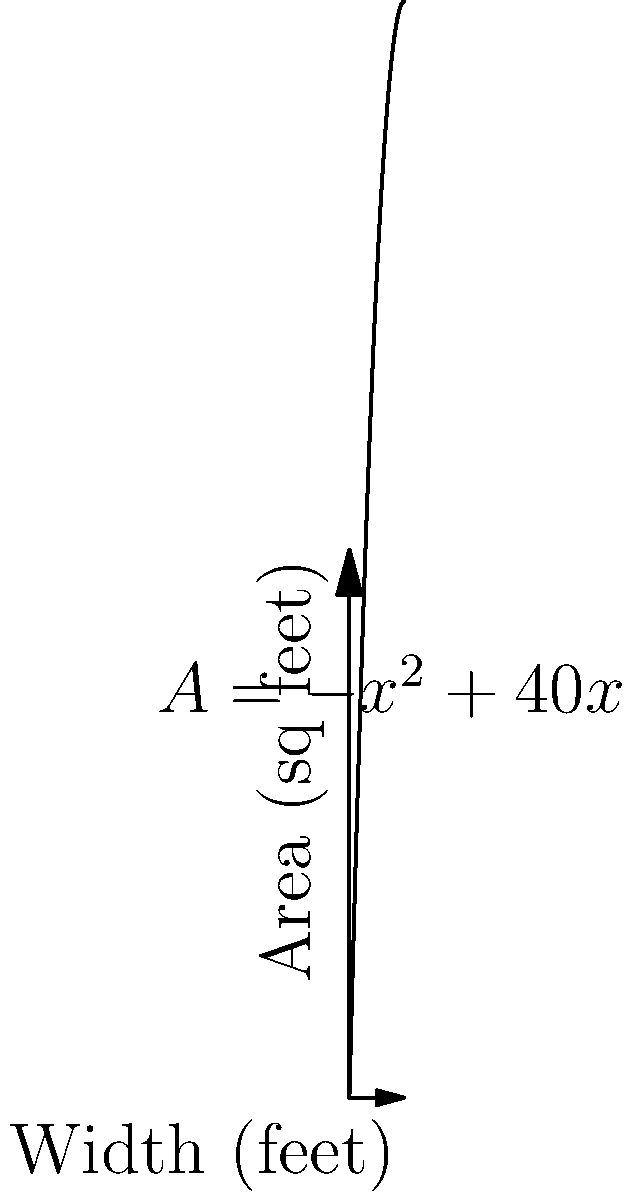You're planning your first big concert and need to optimize the stage layout. The total area of the stage is given by the function $A = -x^2 + 40x$, where $A$ is the area in square feet and $x$ is the width of the stage in feet. What width should you choose to maximize the stage area, and what is the maximum area? To find the maximum area, we need to follow these steps:

1) The function $A = -x^2 + 40x$ is a quadratic function, which forms a parabola when graphed.

2) The maximum point of a parabola occurs at the vertex of the parabola.

3) For a quadratic function in the form $f(x) = ax^2 + bx + c$, the x-coordinate of the vertex is given by $x = -\frac{b}{2a}$.

4) In our case, $a = -1$ and $b = 40$. So:

   $x = -\frac{40}{2(-1)} = \frac{40}{2} = 20$

5) To find the maximum area, we plug this x-value back into our original equation:

   $A = -(20)^2 + 40(20) = -400 + 800 = 400$

Therefore, the stage width should be 20 feet, which will result in a maximum area of 400 square feet.
Answer: Width: 20 feet; Maximum area: 400 sq feet 